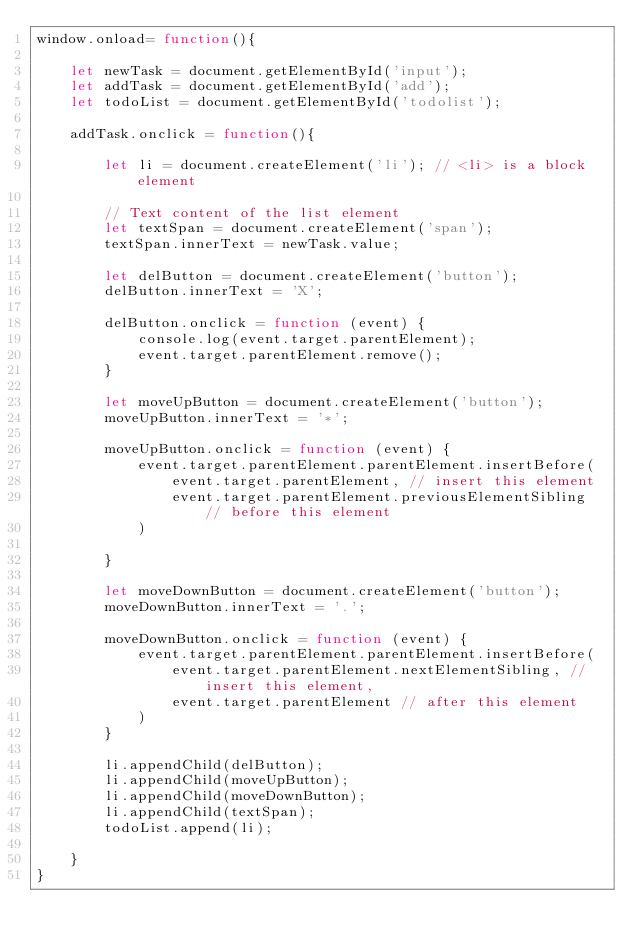<code> <loc_0><loc_0><loc_500><loc_500><_JavaScript_>window.onload= function(){
    
    let newTask = document.getElementById('input');
    let addTask = document.getElementById('add');
    let todoList = document.getElementById('todolist');
    
    addTask.onclick = function(){
        
        let li = document.createElement('li'); // <li> is a block element
        
        // Text content of the list element 
        let textSpan = document.createElement('span');
        textSpan.innerText = newTask.value;

        let delButton = document.createElement('button');
        delButton.innerText = 'X';

        delButton.onclick = function (event) {
            console.log(event.target.parentElement);
            event.target.parentElement.remove();
        }
    
        let moveUpButton = document.createElement('button');
        moveUpButton.innerText = '*';
    
        moveUpButton.onclick = function (event) {
            event.target.parentElement.parentElement.insertBefore(
                event.target.parentElement, // insert this element
                event.target.parentElement.previousElementSibling // before this element
            )

        }

        let moveDownButton = document.createElement('button');
        moveDownButton.innerText = '.';
    
        moveDownButton.onclick = function (event) {
            event.target.parentElement.parentElement.insertBefore(
                event.target.parentElement.nextElementSibling, // insert this element,
                event.target.parentElement // after this element
            )
        }

        li.appendChild(delButton);
        li.appendChild(moveUpButton);
        li.appendChild(moveDownButton);
        li.appendChild(textSpan);
        todoList.append(li);
    
    }
}</code> 